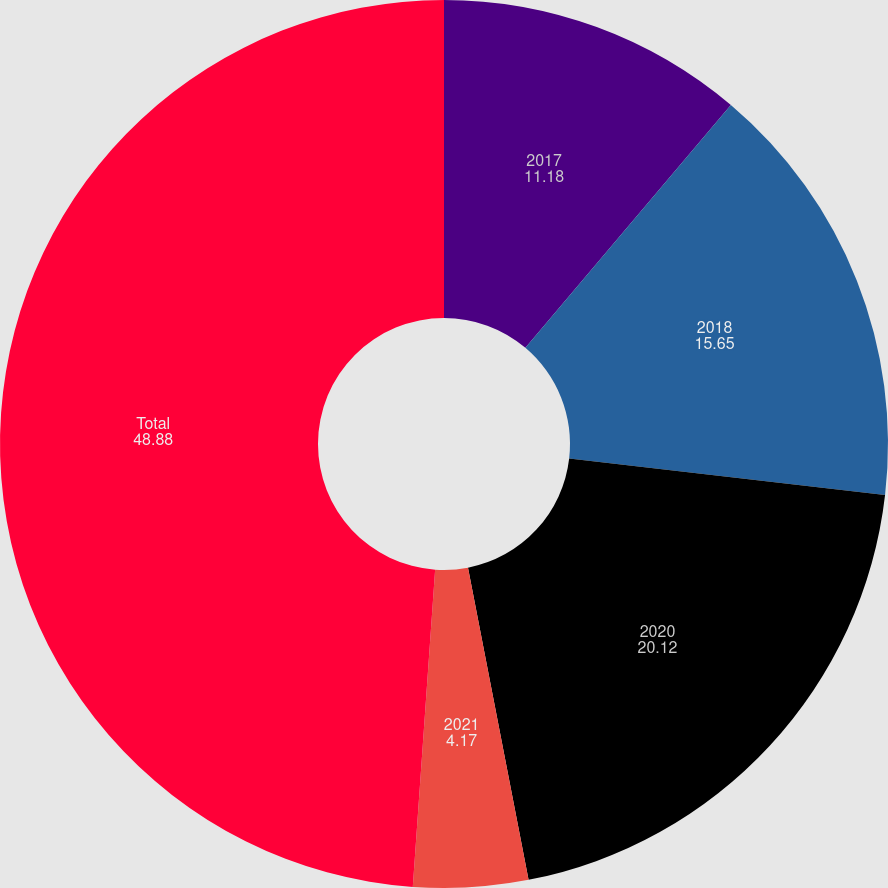Convert chart. <chart><loc_0><loc_0><loc_500><loc_500><pie_chart><fcel>2017<fcel>2018<fcel>2020<fcel>2021<fcel>Total<nl><fcel>11.18%<fcel>15.65%<fcel>20.12%<fcel>4.17%<fcel>48.88%<nl></chart> 